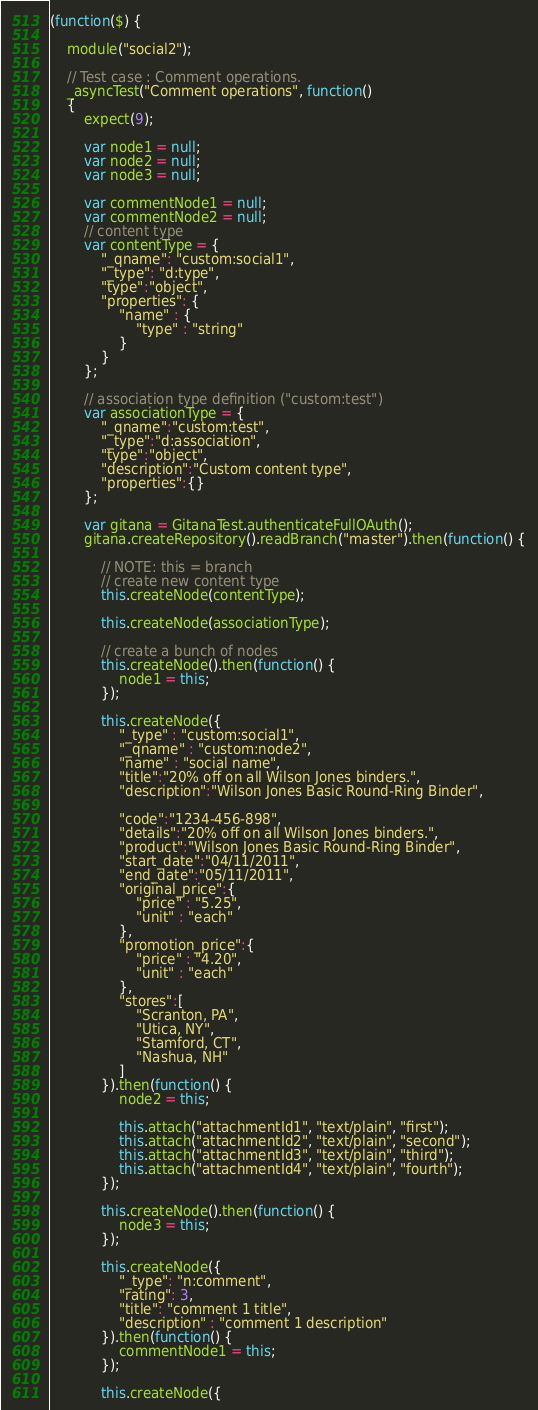Convert code to text. <code><loc_0><loc_0><loc_500><loc_500><_JavaScript_>(function($) {

    module("social2");

    // Test case : Comment operations.
    _asyncTest("Comment operations", function()
    {
        expect(9);

        var node1 = null;
        var node2 = null;
        var node3 = null;

        var commentNode1 = null;
        var commentNode2 = null;
        // content type
        var contentType = {
            "_qname": "custom:social1",
            "_type": "d:type",
            "type":"object",
            "properties": {
                "name" : {
                    "type" : "string"
                }
            }
        };

        // association type definition ("custom:test")
        var associationType = {
            "_qname":"custom:test",
            "_type":"d:association",
            "type":"object",
            "description":"Custom content type",
            "properties":{}
        };

        var gitana = GitanaTest.authenticateFullOAuth();
        gitana.createRepository().readBranch("master").then(function() {

            // NOTE: this = branch
            // create new content type
            this.createNode(contentType);

            this.createNode(associationType);

            // create a bunch of nodes
            this.createNode().then(function() {
                node1 = this;
            });

            this.createNode({
                "_type" : "custom:social1",
                "_qname" : "custom:node2",
                "name" : "social name",
                "title":"20% off on all Wilson Jones binders.",
                "description":"Wilson Jones Basic Round-Ring Binder",

                "code":"1234-456-898",
                "details":"20% off on all Wilson Jones binders.",
                "product":"Wilson Jones Basic Round-Ring Binder",
                "start_date":"04/11/2011",
                "end_date":"05/11/2011",
                "original_price":{
                    "price" : "5.25",
                    "unit" : "each"
                },
                "promotion_price":{
                    "price" : "4.20",
                    "unit" : "each"
                },
                "stores":[
                    "Scranton, PA",
                    "Utica, NY",
                    "Stamford, CT",
                    "Nashua, NH"
                ]
            }).then(function() {
                node2 = this;

                this.attach("attachmentId1", "text/plain", "first");
                this.attach("attachmentId2", "text/plain", "second");
                this.attach("attachmentId3", "text/plain", "third");
                this.attach("attachmentId4", "text/plain", "fourth");
            });

            this.createNode().then(function() {
                node3 = this;
            });

            this.createNode({
                "_type": "n:comment",
                "rating": 3,
                "title": "comment 1 title",
                "description" : "comment 1 description"
            }).then(function() {
                commentNode1 = this;
            });

            this.createNode({</code> 